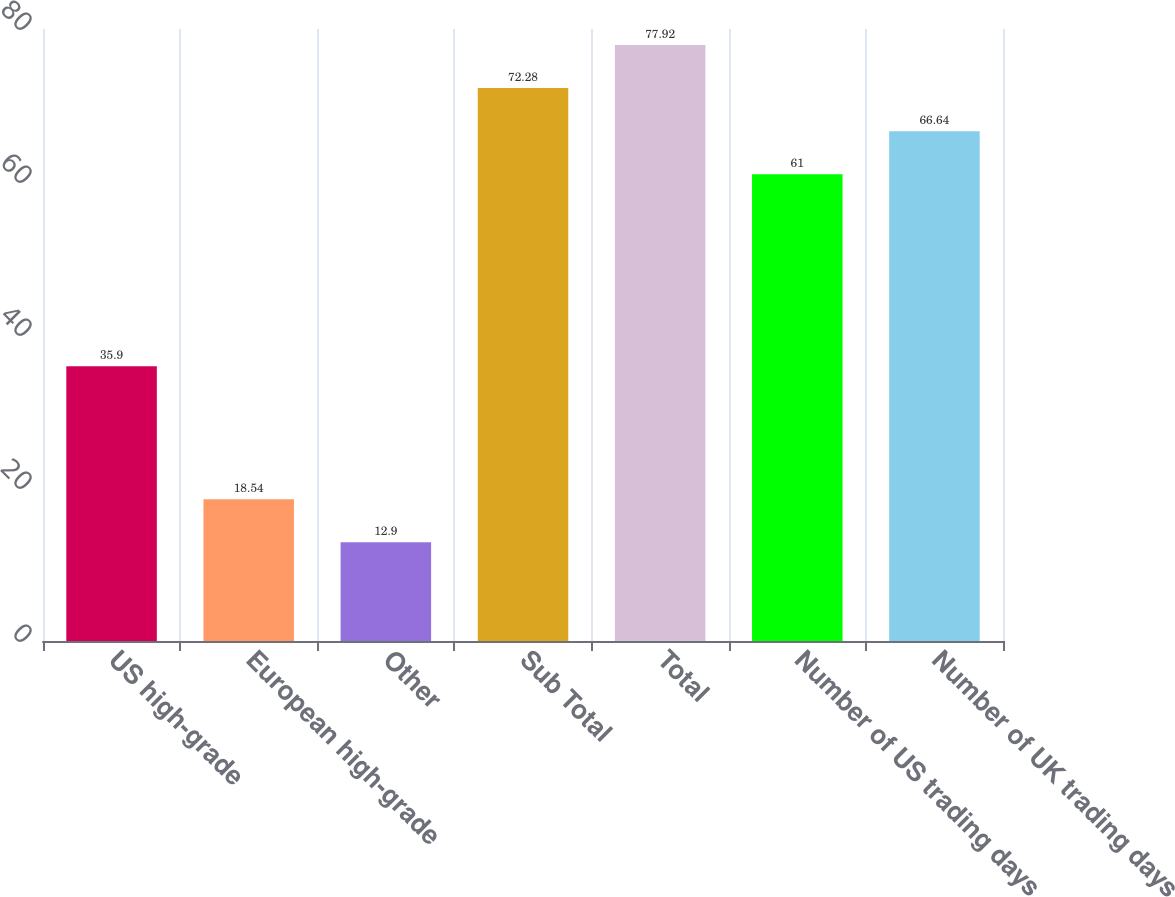Convert chart to OTSL. <chart><loc_0><loc_0><loc_500><loc_500><bar_chart><fcel>US high-grade<fcel>European high-grade<fcel>Other<fcel>Sub Total<fcel>Total<fcel>Number of US trading days<fcel>Number of UK trading days<nl><fcel>35.9<fcel>18.54<fcel>12.9<fcel>72.28<fcel>77.92<fcel>61<fcel>66.64<nl></chart> 